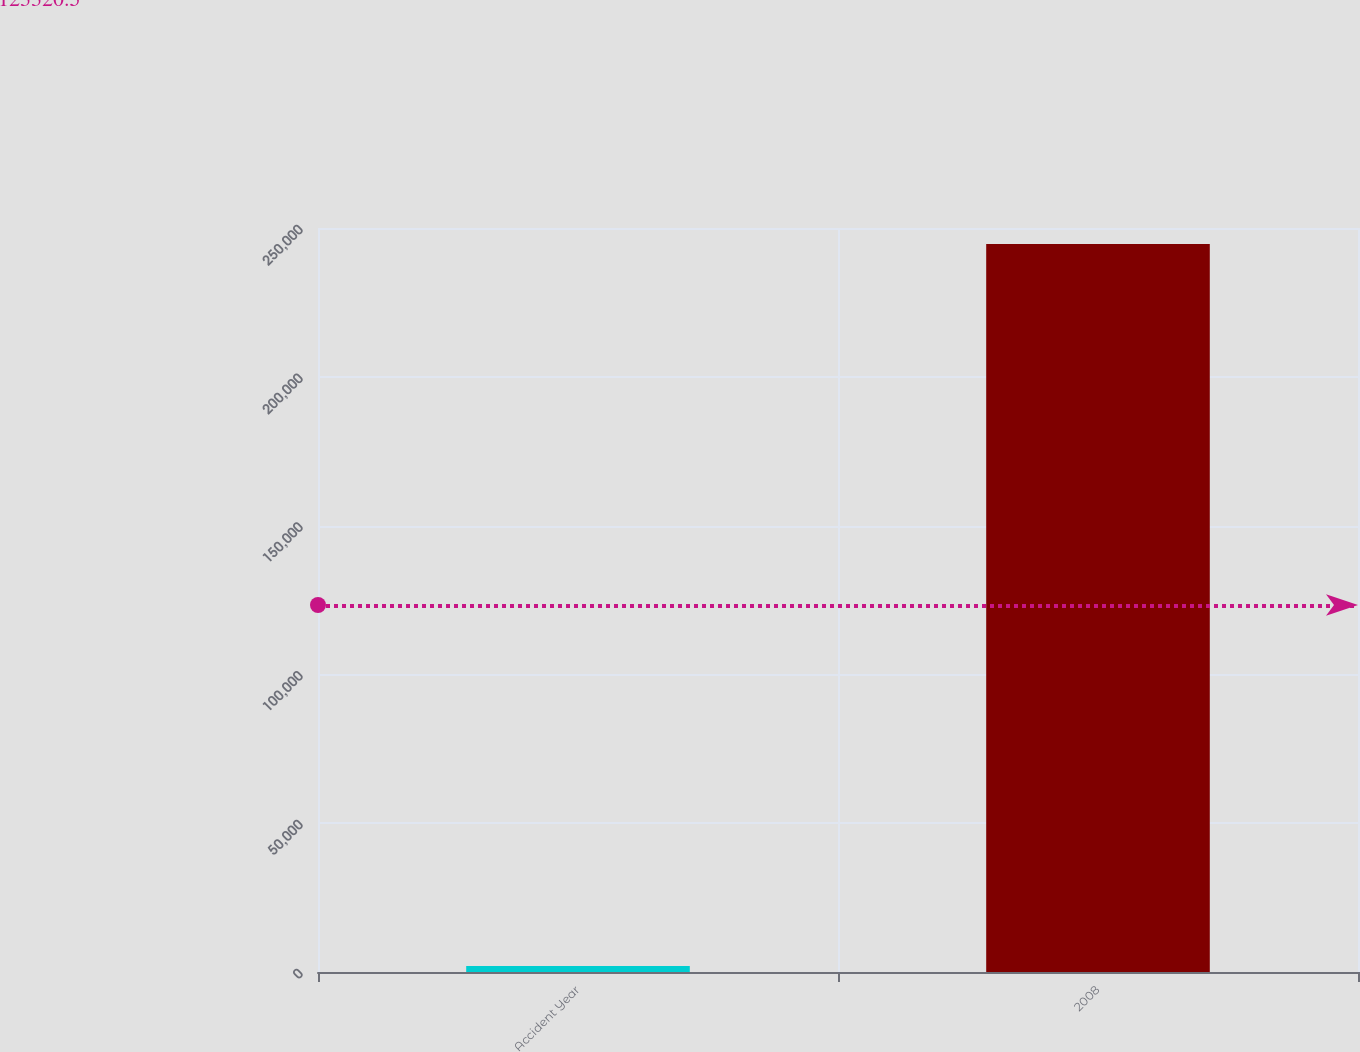<chart> <loc_0><loc_0><loc_500><loc_500><bar_chart><fcel>Accident Year<fcel>2008<nl><fcel>2008<fcel>244633<nl></chart> 